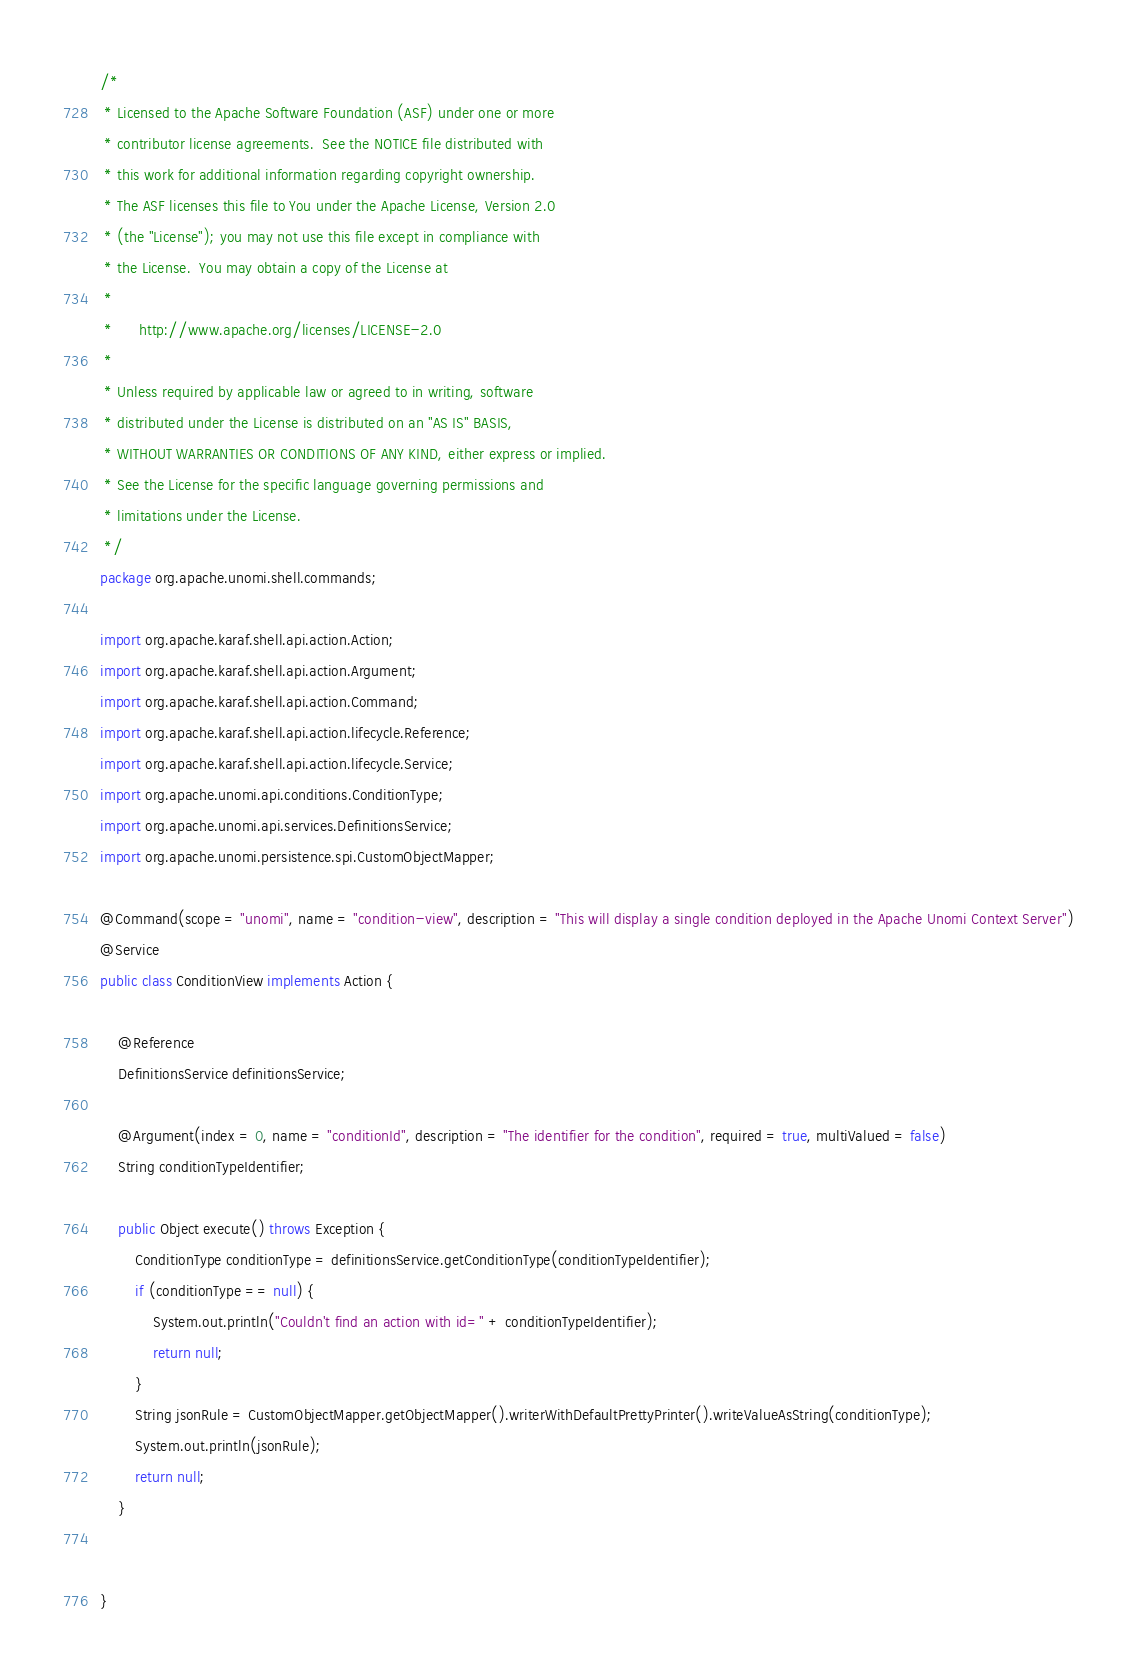Convert code to text. <code><loc_0><loc_0><loc_500><loc_500><_Java_>/*
 * Licensed to the Apache Software Foundation (ASF) under one or more
 * contributor license agreements.  See the NOTICE file distributed with
 * this work for additional information regarding copyright ownership.
 * The ASF licenses this file to You under the Apache License, Version 2.0
 * (the "License"); you may not use this file except in compliance with
 * the License.  You may obtain a copy of the License at
 *
 *      http://www.apache.org/licenses/LICENSE-2.0
 *
 * Unless required by applicable law or agreed to in writing, software
 * distributed under the License is distributed on an "AS IS" BASIS,
 * WITHOUT WARRANTIES OR CONDITIONS OF ANY KIND, either express or implied.
 * See the License for the specific language governing permissions and
 * limitations under the License.
 */
package org.apache.unomi.shell.commands;

import org.apache.karaf.shell.api.action.Action;
import org.apache.karaf.shell.api.action.Argument;
import org.apache.karaf.shell.api.action.Command;
import org.apache.karaf.shell.api.action.lifecycle.Reference;
import org.apache.karaf.shell.api.action.lifecycle.Service;
import org.apache.unomi.api.conditions.ConditionType;
import org.apache.unomi.api.services.DefinitionsService;
import org.apache.unomi.persistence.spi.CustomObjectMapper;

@Command(scope = "unomi", name = "condition-view", description = "This will display a single condition deployed in the Apache Unomi Context Server")
@Service
public class ConditionView implements Action {

    @Reference
    DefinitionsService definitionsService;

    @Argument(index = 0, name = "conditionId", description = "The identifier for the condition", required = true, multiValued = false)
    String conditionTypeIdentifier;

    public Object execute() throws Exception {
        ConditionType conditionType = definitionsService.getConditionType(conditionTypeIdentifier);
        if (conditionType == null) {
            System.out.println("Couldn't find an action with id=" + conditionTypeIdentifier);
            return null;
        }
        String jsonRule = CustomObjectMapper.getObjectMapper().writerWithDefaultPrettyPrinter().writeValueAsString(conditionType);
        System.out.println(jsonRule);
        return null;
    }


}
</code> 